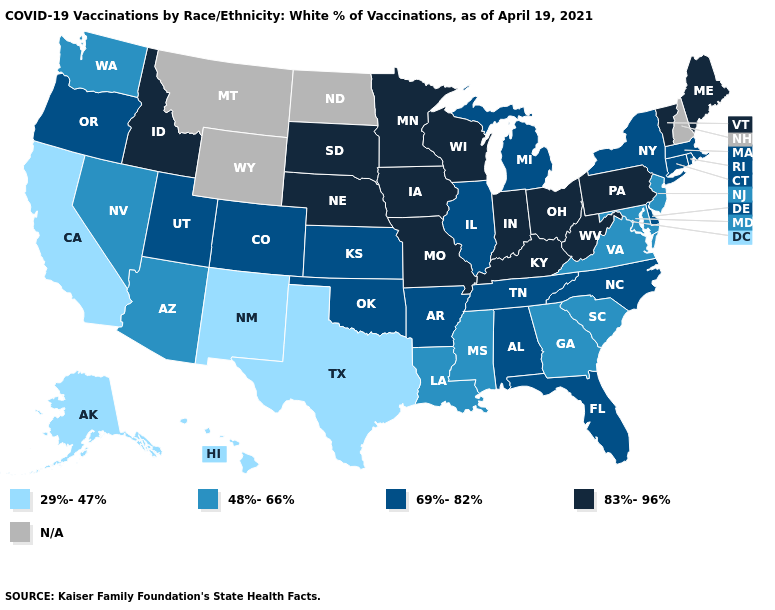What is the value of Illinois?
Keep it brief. 69%-82%. Among the states that border California , which have the lowest value?
Answer briefly. Arizona, Nevada. Does Kentucky have the highest value in the USA?
Short answer required. Yes. What is the value of Utah?
Concise answer only. 69%-82%. Does Ohio have the highest value in the MidWest?
Keep it brief. Yes. Does Illinois have the highest value in the USA?
Quick response, please. No. Does Alaska have the lowest value in the West?
Keep it brief. Yes. How many symbols are there in the legend?
Give a very brief answer. 5. Name the states that have a value in the range 48%-66%?
Write a very short answer. Arizona, Georgia, Louisiana, Maryland, Mississippi, Nevada, New Jersey, South Carolina, Virginia, Washington. What is the value of South Carolina?
Answer briefly. 48%-66%. Does the first symbol in the legend represent the smallest category?
Answer briefly. Yes. Does Kansas have the highest value in the USA?
Concise answer only. No. How many symbols are there in the legend?
Quick response, please. 5. Which states hav the highest value in the West?
Keep it brief. Idaho. 